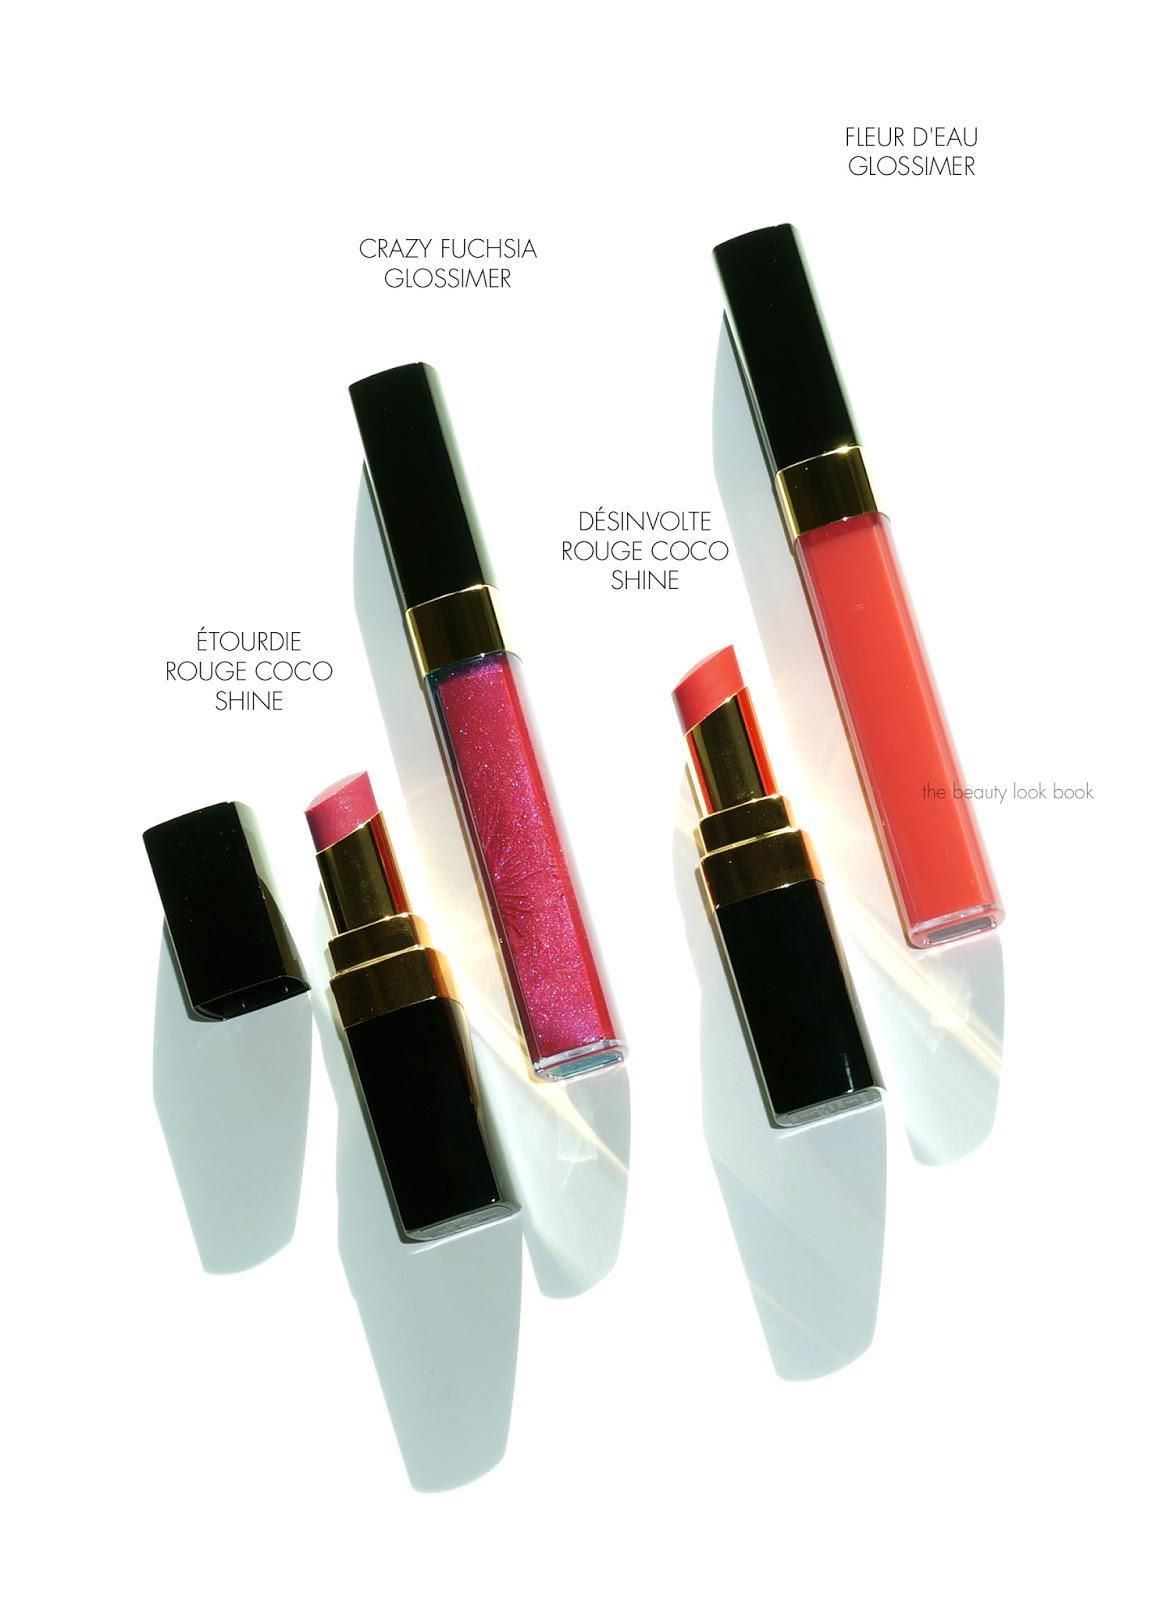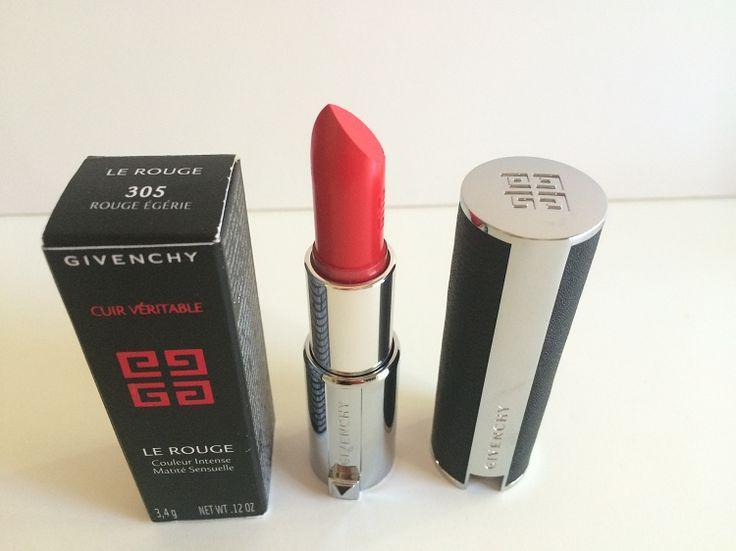The first image is the image on the left, the second image is the image on the right. Analyze the images presented: Is the assertion "An image contains lip tints in little champagne bottles." valid? Answer yes or no. No. 